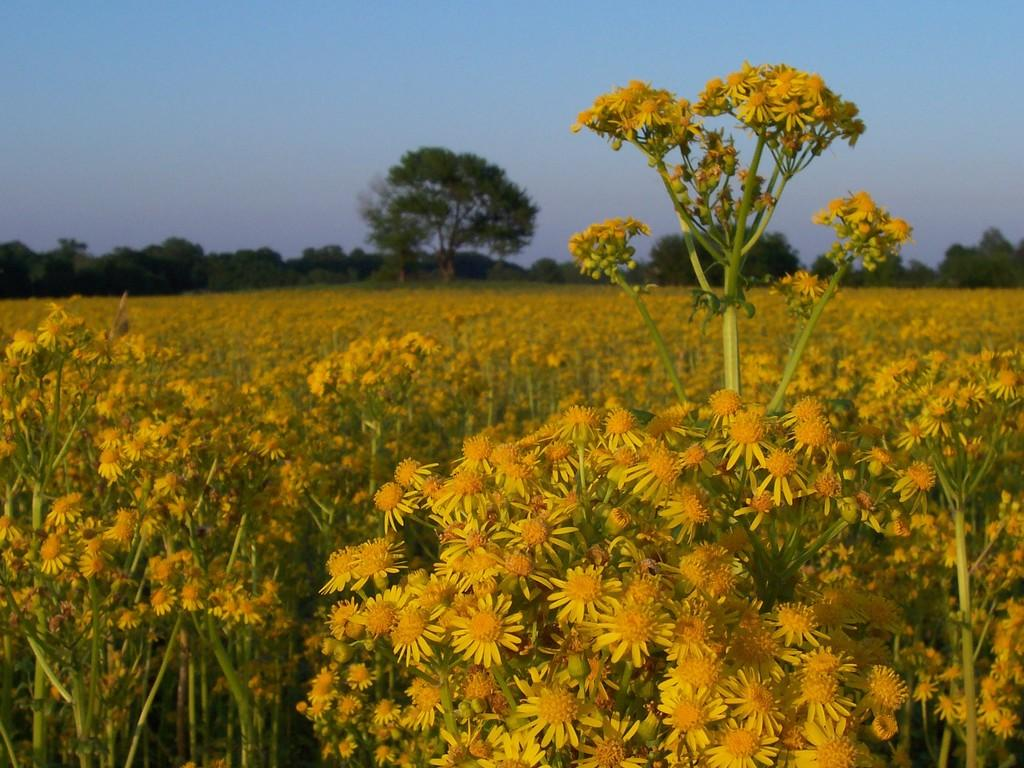What type of flora can be seen in the image? There are flowers and plants in the image. What color are the flowers in the image? The flowers are yellow in color. What color are the plants in the image? The plants are green in color. What can be seen in the background of the image? There are trees and the sky visible in the background of the image. What type of calculator can be seen in the image? There is no calculator present in the image. What direction are the flowers facing in the image? The direction the flowers are facing cannot be determined from the image, as they are not shown facing a specific direction. 